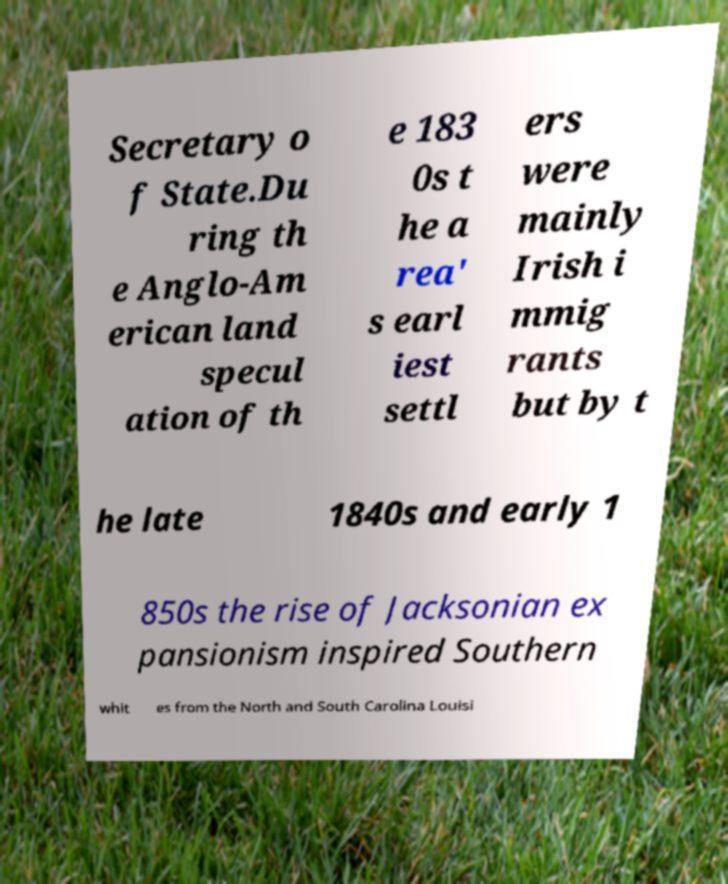Please read and relay the text visible in this image. What does it say? Secretary o f State.Du ring th e Anglo-Am erican land specul ation of th e 183 0s t he a rea' s earl iest settl ers were mainly Irish i mmig rants but by t he late 1840s and early 1 850s the rise of Jacksonian ex pansionism inspired Southern whit es from the North and South Carolina Louisi 